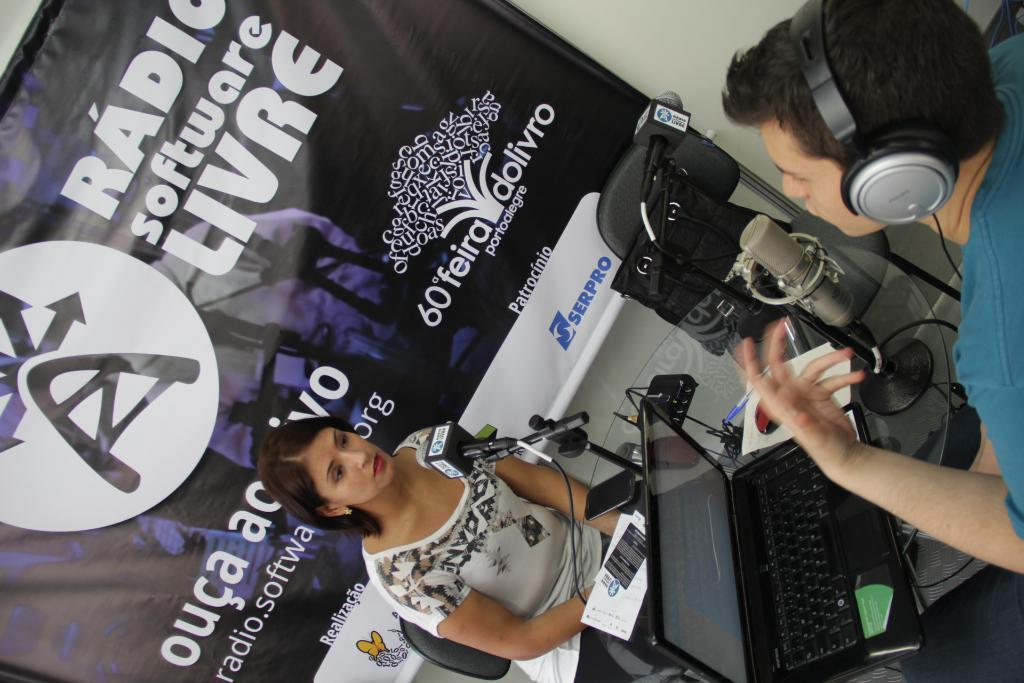Provide a one-sentence caption for the provided image. A radio interview is taking place in front of a sign that says radio software livre. 